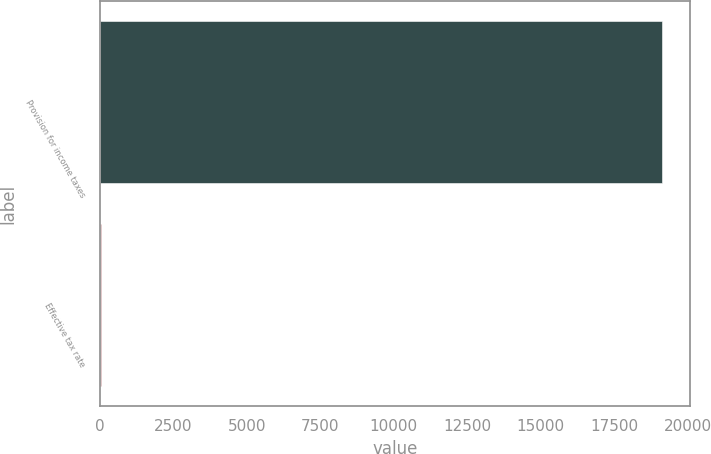<chart> <loc_0><loc_0><loc_500><loc_500><bar_chart><fcel>Provision for income taxes<fcel>Effective tax rate<nl><fcel>19121<fcel>26.4<nl></chart> 